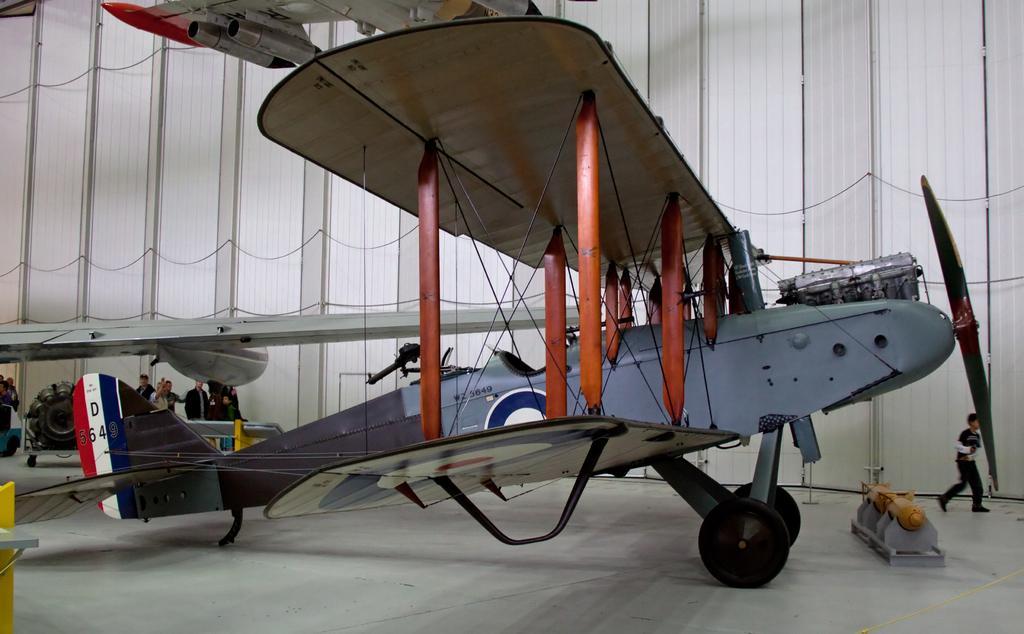Could you give a brief overview of what you see in this image? In this image there is an airplane and a few objects on the floor, there are a few people standing and walking. In the background there is a wall. 